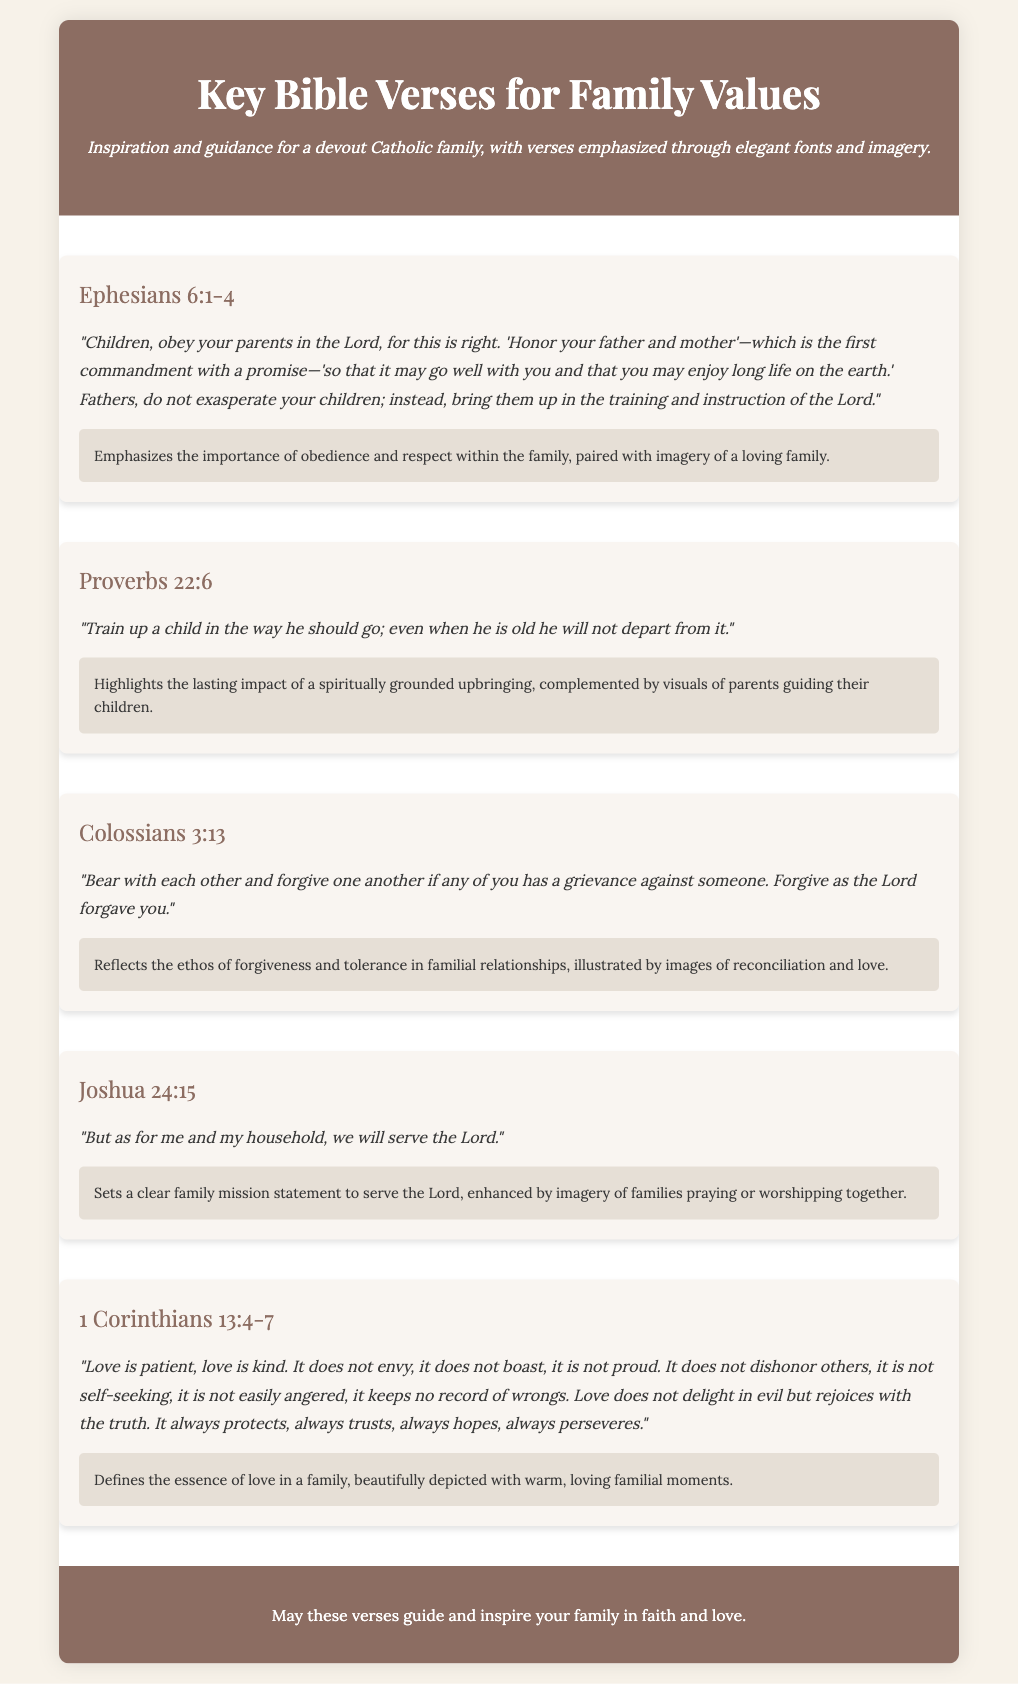what is the title of the document? The title, prominently displayed at the top, is a clear representation of the content of the document.
Answer: Key Bible Verses for Family Values how many verses are listed in the document? Each verse is presented as a separate list item, enabling readers to easily count them.
Answer: 5 what is the reference of the first verse? The reference is mentioned in a distinct format at the beginning of each verse item.
Answer: Ephesians 6:1-4 which verse emphasizes the importance of training children? The document provides a specific verse that directly discusses the upbringing of children.
Answer: Proverbs 22:6 what significant theme is associated with Colossians 3:13? Each verse is accompanied by a description that elaborates on its significance and core message.
Answer: Forgiveness what action does Joshua 24:15 declare for the household? The verse outlines a commitment that the family should adopt regarding their faith and practices.
Answer: Serve the Lord which book of the Bible contains the verse about love? Each verse is attributed to its original book, and this particular verse is well-known for its depiction of love.
Answer: 1 Corinthians what is the background color of the document? The colors used are part of the design elements intended to create an inviting visual experience for readers.
Answer: #f7f2e9 